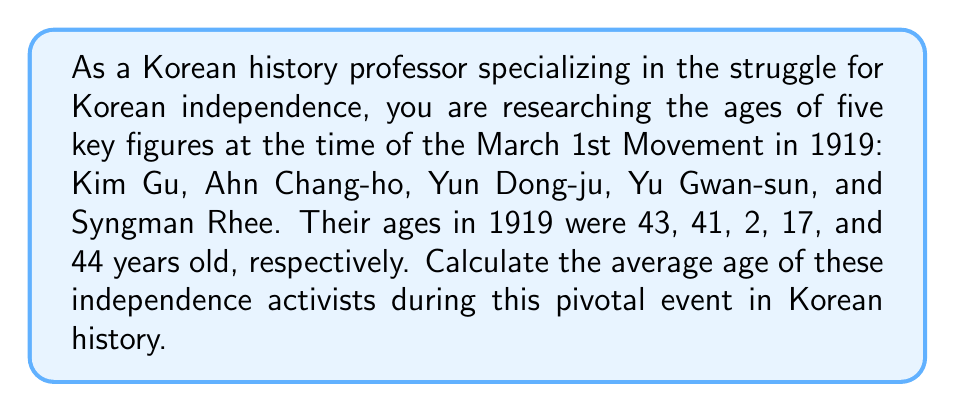Give your solution to this math problem. To find the average age of these key figures, we need to:

1. Sum up all the ages
2. Divide the sum by the number of people

Let's break it down step-by-step:

1. Sum of ages:
   $$ 43 + 41 + 2 + 17 + 44 = 147 $$

2. Number of people: 5

3. Calculate the average:
   $$ \text{Average} = \frac{\text{Sum of ages}}{\text{Number of people}} $$
   $$ \text{Average} = \frac{147}{5} $$
   $$ \text{Average} = 29.4 $$

Therefore, the average age of these five key figures in the Korean independence struggle during the March 1st Movement in 1919 was 29.4 years old.
Answer: $29.4$ years old 